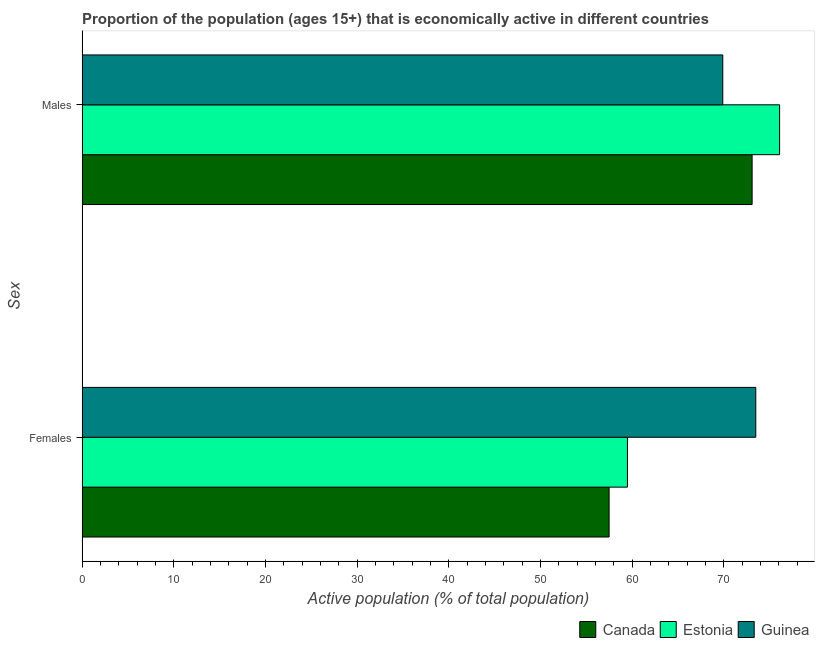How many groups of bars are there?
Give a very brief answer. 2. Are the number of bars on each tick of the Y-axis equal?
Provide a short and direct response. Yes. How many bars are there on the 1st tick from the bottom?
Ensure brevity in your answer.  3. What is the label of the 1st group of bars from the top?
Provide a succinct answer. Males. What is the percentage of economically active female population in Canada?
Provide a short and direct response. 57.5. Across all countries, what is the maximum percentage of economically active female population?
Ensure brevity in your answer.  73.5. Across all countries, what is the minimum percentage of economically active male population?
Your answer should be very brief. 69.9. In which country was the percentage of economically active male population maximum?
Your response must be concise. Estonia. What is the total percentage of economically active male population in the graph?
Your response must be concise. 219.1. What is the difference between the percentage of economically active female population in Guinea and the percentage of economically active male population in Canada?
Give a very brief answer. 0.4. What is the average percentage of economically active male population per country?
Your answer should be very brief. 73.03. What is the difference between the percentage of economically active female population and percentage of economically active male population in Canada?
Make the answer very short. -15.6. In how many countries, is the percentage of economically active male population greater than 74 %?
Provide a succinct answer. 1. What is the ratio of the percentage of economically active male population in Guinea to that in Estonia?
Provide a succinct answer. 0.92. Is the percentage of economically active male population in Guinea less than that in Canada?
Give a very brief answer. Yes. In how many countries, is the percentage of economically active male population greater than the average percentage of economically active male population taken over all countries?
Offer a very short reply. 2. What does the 1st bar from the top in Males represents?
Make the answer very short. Guinea. What does the 2nd bar from the bottom in Females represents?
Give a very brief answer. Estonia. How many bars are there?
Your answer should be very brief. 6. What is the difference between two consecutive major ticks on the X-axis?
Your answer should be compact. 10. Does the graph contain any zero values?
Keep it short and to the point. No. Does the graph contain grids?
Make the answer very short. No. Where does the legend appear in the graph?
Give a very brief answer. Bottom right. What is the title of the graph?
Give a very brief answer. Proportion of the population (ages 15+) that is economically active in different countries. Does "Kuwait" appear as one of the legend labels in the graph?
Offer a terse response. No. What is the label or title of the X-axis?
Your answer should be compact. Active population (% of total population). What is the label or title of the Y-axis?
Keep it short and to the point. Sex. What is the Active population (% of total population) of Canada in Females?
Provide a succinct answer. 57.5. What is the Active population (% of total population) of Estonia in Females?
Make the answer very short. 59.5. What is the Active population (% of total population) of Guinea in Females?
Make the answer very short. 73.5. What is the Active population (% of total population) in Canada in Males?
Offer a very short reply. 73.1. What is the Active population (% of total population) in Estonia in Males?
Give a very brief answer. 76.1. What is the Active population (% of total population) of Guinea in Males?
Keep it short and to the point. 69.9. Across all Sex, what is the maximum Active population (% of total population) in Canada?
Keep it short and to the point. 73.1. Across all Sex, what is the maximum Active population (% of total population) in Estonia?
Ensure brevity in your answer.  76.1. Across all Sex, what is the maximum Active population (% of total population) of Guinea?
Keep it short and to the point. 73.5. Across all Sex, what is the minimum Active population (% of total population) of Canada?
Your answer should be compact. 57.5. Across all Sex, what is the minimum Active population (% of total population) of Estonia?
Your answer should be very brief. 59.5. Across all Sex, what is the minimum Active population (% of total population) of Guinea?
Offer a terse response. 69.9. What is the total Active population (% of total population) in Canada in the graph?
Provide a short and direct response. 130.6. What is the total Active population (% of total population) of Estonia in the graph?
Ensure brevity in your answer.  135.6. What is the total Active population (% of total population) in Guinea in the graph?
Your answer should be compact. 143.4. What is the difference between the Active population (% of total population) of Canada in Females and that in Males?
Offer a terse response. -15.6. What is the difference between the Active population (% of total population) in Estonia in Females and that in Males?
Provide a succinct answer. -16.6. What is the difference between the Active population (% of total population) in Guinea in Females and that in Males?
Give a very brief answer. 3.6. What is the difference between the Active population (% of total population) of Canada in Females and the Active population (% of total population) of Estonia in Males?
Offer a terse response. -18.6. What is the difference between the Active population (% of total population) of Canada in Females and the Active population (% of total population) of Guinea in Males?
Keep it short and to the point. -12.4. What is the average Active population (% of total population) of Canada per Sex?
Offer a very short reply. 65.3. What is the average Active population (% of total population) in Estonia per Sex?
Ensure brevity in your answer.  67.8. What is the average Active population (% of total population) of Guinea per Sex?
Keep it short and to the point. 71.7. What is the difference between the Active population (% of total population) of Canada and Active population (% of total population) of Guinea in Females?
Provide a succinct answer. -16. What is the difference between the Active population (% of total population) of Canada and Active population (% of total population) of Estonia in Males?
Your response must be concise. -3. What is the difference between the Active population (% of total population) in Canada and Active population (% of total population) in Guinea in Males?
Your answer should be compact. 3.2. What is the difference between the Active population (% of total population) of Estonia and Active population (% of total population) of Guinea in Males?
Your answer should be very brief. 6.2. What is the ratio of the Active population (% of total population) in Canada in Females to that in Males?
Give a very brief answer. 0.79. What is the ratio of the Active population (% of total population) in Estonia in Females to that in Males?
Your answer should be very brief. 0.78. What is the ratio of the Active population (% of total population) in Guinea in Females to that in Males?
Offer a very short reply. 1.05. What is the difference between the highest and the second highest Active population (% of total population) of Estonia?
Your answer should be very brief. 16.6. What is the difference between the highest and the lowest Active population (% of total population) of Estonia?
Your answer should be compact. 16.6. What is the difference between the highest and the lowest Active population (% of total population) of Guinea?
Keep it short and to the point. 3.6. 